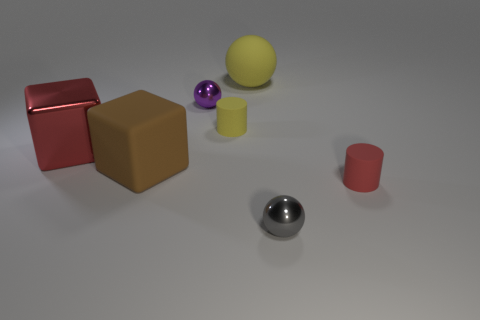Subtract all yellow spheres. How many spheres are left? 2 Subtract all cyan balls. Subtract all green blocks. How many balls are left? 3 Add 2 large metal cubes. How many objects exist? 9 Add 7 large objects. How many large objects exist? 10 Subtract 0 brown balls. How many objects are left? 7 Subtract all balls. How many objects are left? 4 Subtract all big brown matte things. Subtract all purple objects. How many objects are left? 5 Add 7 red objects. How many red objects are left? 9 